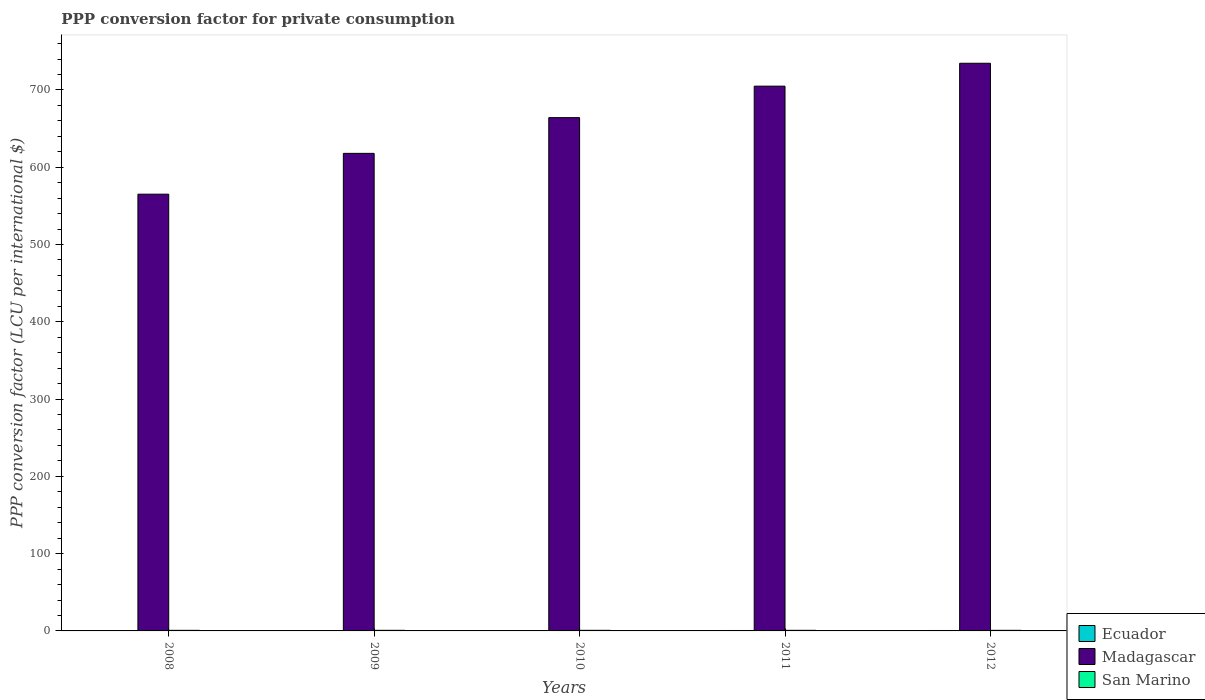How many groups of bars are there?
Offer a very short reply. 5. What is the label of the 2nd group of bars from the left?
Ensure brevity in your answer.  2009. What is the PPP conversion factor for private consumption in San Marino in 2012?
Offer a very short reply. 0.78. Across all years, what is the maximum PPP conversion factor for private consumption in Madagascar?
Your response must be concise. 734.54. Across all years, what is the minimum PPP conversion factor for private consumption in San Marino?
Your answer should be compact. 0.76. In which year was the PPP conversion factor for private consumption in San Marino maximum?
Your answer should be very brief. 2010. In which year was the PPP conversion factor for private consumption in San Marino minimum?
Provide a short and direct response. 2008. What is the total PPP conversion factor for private consumption in San Marino in the graph?
Provide a succinct answer. 3.86. What is the difference between the PPP conversion factor for private consumption in Madagascar in 2008 and that in 2011?
Your response must be concise. -139.79. What is the difference between the PPP conversion factor for private consumption in San Marino in 2008 and the PPP conversion factor for private consumption in Madagascar in 2011?
Your response must be concise. -704.16. What is the average PPP conversion factor for private consumption in Madagascar per year?
Make the answer very short. 657.34. In the year 2012, what is the difference between the PPP conversion factor for private consumption in Ecuador and PPP conversion factor for private consumption in San Marino?
Provide a short and direct response. -0.22. What is the ratio of the PPP conversion factor for private consumption in Ecuador in 2009 to that in 2011?
Give a very brief answer. 0.97. What is the difference between the highest and the second highest PPP conversion factor for private consumption in San Marino?
Your response must be concise. 0. What is the difference between the highest and the lowest PPP conversion factor for private consumption in San Marino?
Offer a very short reply. 0.03. In how many years, is the PPP conversion factor for private consumption in San Marino greater than the average PPP conversion factor for private consumption in San Marino taken over all years?
Your answer should be compact. 4. What does the 2nd bar from the left in 2010 represents?
Keep it short and to the point. Madagascar. What does the 2nd bar from the right in 2010 represents?
Make the answer very short. Madagascar. How many bars are there?
Your response must be concise. 15. Are all the bars in the graph horizontal?
Offer a terse response. No. Are the values on the major ticks of Y-axis written in scientific E-notation?
Provide a short and direct response. No. How many legend labels are there?
Keep it short and to the point. 3. How are the legend labels stacked?
Offer a very short reply. Vertical. What is the title of the graph?
Your answer should be very brief. PPP conversion factor for private consumption. Does "New Zealand" appear as one of the legend labels in the graph?
Your response must be concise. No. What is the label or title of the X-axis?
Your response must be concise. Years. What is the label or title of the Y-axis?
Provide a succinct answer. PPP conversion factor (LCU per international $). What is the PPP conversion factor (LCU per international $) in Ecuador in 2008?
Provide a succinct answer. 0.5. What is the PPP conversion factor (LCU per international $) in Madagascar in 2008?
Offer a terse response. 565.12. What is the PPP conversion factor (LCU per international $) in San Marino in 2008?
Offer a very short reply. 0.76. What is the PPP conversion factor (LCU per international $) in Ecuador in 2009?
Offer a terse response. 0.53. What is the PPP conversion factor (LCU per international $) of Madagascar in 2009?
Provide a succinct answer. 617.94. What is the PPP conversion factor (LCU per international $) in San Marino in 2009?
Your response must be concise. 0.77. What is the PPP conversion factor (LCU per international $) in Ecuador in 2010?
Make the answer very short. 0.54. What is the PPP conversion factor (LCU per international $) in Madagascar in 2010?
Ensure brevity in your answer.  664.18. What is the PPP conversion factor (LCU per international $) of San Marino in 2010?
Provide a short and direct response. 0.78. What is the PPP conversion factor (LCU per international $) of Ecuador in 2011?
Offer a terse response. 0.55. What is the PPP conversion factor (LCU per international $) of Madagascar in 2011?
Offer a very short reply. 704.91. What is the PPP conversion factor (LCU per international $) of San Marino in 2011?
Keep it short and to the point. 0.77. What is the PPP conversion factor (LCU per international $) of Ecuador in 2012?
Offer a terse response. 0.56. What is the PPP conversion factor (LCU per international $) of Madagascar in 2012?
Ensure brevity in your answer.  734.54. What is the PPP conversion factor (LCU per international $) in San Marino in 2012?
Offer a terse response. 0.78. Across all years, what is the maximum PPP conversion factor (LCU per international $) in Ecuador?
Make the answer very short. 0.56. Across all years, what is the maximum PPP conversion factor (LCU per international $) of Madagascar?
Offer a terse response. 734.54. Across all years, what is the maximum PPP conversion factor (LCU per international $) in San Marino?
Provide a succinct answer. 0.78. Across all years, what is the minimum PPP conversion factor (LCU per international $) in Ecuador?
Your answer should be compact. 0.5. Across all years, what is the minimum PPP conversion factor (LCU per international $) of Madagascar?
Give a very brief answer. 565.12. Across all years, what is the minimum PPP conversion factor (LCU per international $) of San Marino?
Your answer should be compact. 0.76. What is the total PPP conversion factor (LCU per international $) of Ecuador in the graph?
Ensure brevity in your answer.  2.68. What is the total PPP conversion factor (LCU per international $) of Madagascar in the graph?
Your answer should be compact. 3286.7. What is the total PPP conversion factor (LCU per international $) in San Marino in the graph?
Provide a short and direct response. 3.86. What is the difference between the PPP conversion factor (LCU per international $) of Ecuador in 2008 and that in 2009?
Your response must be concise. -0.03. What is the difference between the PPP conversion factor (LCU per international $) in Madagascar in 2008 and that in 2009?
Your response must be concise. -52.81. What is the difference between the PPP conversion factor (LCU per international $) in San Marino in 2008 and that in 2009?
Offer a very short reply. -0.02. What is the difference between the PPP conversion factor (LCU per international $) in Ecuador in 2008 and that in 2010?
Offer a terse response. -0.04. What is the difference between the PPP conversion factor (LCU per international $) in Madagascar in 2008 and that in 2010?
Make the answer very short. -99.06. What is the difference between the PPP conversion factor (LCU per international $) in San Marino in 2008 and that in 2010?
Offer a very short reply. -0.03. What is the difference between the PPP conversion factor (LCU per international $) of Ecuador in 2008 and that in 2011?
Your response must be concise. -0.04. What is the difference between the PPP conversion factor (LCU per international $) in Madagascar in 2008 and that in 2011?
Your answer should be very brief. -139.79. What is the difference between the PPP conversion factor (LCU per international $) of San Marino in 2008 and that in 2011?
Your response must be concise. -0.02. What is the difference between the PPP conversion factor (LCU per international $) of Ecuador in 2008 and that in 2012?
Provide a short and direct response. -0.06. What is the difference between the PPP conversion factor (LCU per international $) of Madagascar in 2008 and that in 2012?
Make the answer very short. -169.41. What is the difference between the PPP conversion factor (LCU per international $) of San Marino in 2008 and that in 2012?
Your answer should be compact. -0.02. What is the difference between the PPP conversion factor (LCU per international $) in Ecuador in 2009 and that in 2010?
Provide a short and direct response. -0.01. What is the difference between the PPP conversion factor (LCU per international $) of Madagascar in 2009 and that in 2010?
Provide a short and direct response. -46.25. What is the difference between the PPP conversion factor (LCU per international $) in San Marino in 2009 and that in 2010?
Give a very brief answer. -0.01. What is the difference between the PPP conversion factor (LCU per international $) of Ecuador in 2009 and that in 2011?
Offer a very short reply. -0.02. What is the difference between the PPP conversion factor (LCU per international $) of Madagascar in 2009 and that in 2011?
Provide a succinct answer. -86.97. What is the difference between the PPP conversion factor (LCU per international $) of San Marino in 2009 and that in 2011?
Make the answer very short. 0. What is the difference between the PPP conversion factor (LCU per international $) in Ecuador in 2009 and that in 2012?
Offer a very short reply. -0.03. What is the difference between the PPP conversion factor (LCU per international $) of Madagascar in 2009 and that in 2012?
Make the answer very short. -116.6. What is the difference between the PPP conversion factor (LCU per international $) in San Marino in 2009 and that in 2012?
Make the answer very short. -0. What is the difference between the PPP conversion factor (LCU per international $) in Ecuador in 2010 and that in 2011?
Offer a terse response. -0.01. What is the difference between the PPP conversion factor (LCU per international $) of Madagascar in 2010 and that in 2011?
Give a very brief answer. -40.73. What is the difference between the PPP conversion factor (LCU per international $) of San Marino in 2010 and that in 2011?
Give a very brief answer. 0.01. What is the difference between the PPP conversion factor (LCU per international $) in Ecuador in 2010 and that in 2012?
Ensure brevity in your answer.  -0.02. What is the difference between the PPP conversion factor (LCU per international $) of Madagascar in 2010 and that in 2012?
Offer a terse response. -70.35. What is the difference between the PPP conversion factor (LCU per international $) of San Marino in 2010 and that in 2012?
Your answer should be compact. 0. What is the difference between the PPP conversion factor (LCU per international $) in Ecuador in 2011 and that in 2012?
Provide a succinct answer. -0.02. What is the difference between the PPP conversion factor (LCU per international $) in Madagascar in 2011 and that in 2012?
Provide a short and direct response. -29.62. What is the difference between the PPP conversion factor (LCU per international $) of San Marino in 2011 and that in 2012?
Offer a very short reply. -0.01. What is the difference between the PPP conversion factor (LCU per international $) of Ecuador in 2008 and the PPP conversion factor (LCU per international $) of Madagascar in 2009?
Offer a terse response. -617.44. What is the difference between the PPP conversion factor (LCU per international $) in Ecuador in 2008 and the PPP conversion factor (LCU per international $) in San Marino in 2009?
Provide a succinct answer. -0.27. What is the difference between the PPP conversion factor (LCU per international $) of Madagascar in 2008 and the PPP conversion factor (LCU per international $) of San Marino in 2009?
Offer a very short reply. 564.35. What is the difference between the PPP conversion factor (LCU per international $) in Ecuador in 2008 and the PPP conversion factor (LCU per international $) in Madagascar in 2010?
Offer a terse response. -663.68. What is the difference between the PPP conversion factor (LCU per international $) in Ecuador in 2008 and the PPP conversion factor (LCU per international $) in San Marino in 2010?
Your answer should be very brief. -0.28. What is the difference between the PPP conversion factor (LCU per international $) of Madagascar in 2008 and the PPP conversion factor (LCU per international $) of San Marino in 2010?
Offer a terse response. 564.34. What is the difference between the PPP conversion factor (LCU per international $) in Ecuador in 2008 and the PPP conversion factor (LCU per international $) in Madagascar in 2011?
Your answer should be very brief. -704.41. What is the difference between the PPP conversion factor (LCU per international $) of Ecuador in 2008 and the PPP conversion factor (LCU per international $) of San Marino in 2011?
Your answer should be compact. -0.27. What is the difference between the PPP conversion factor (LCU per international $) in Madagascar in 2008 and the PPP conversion factor (LCU per international $) in San Marino in 2011?
Keep it short and to the point. 564.35. What is the difference between the PPP conversion factor (LCU per international $) in Ecuador in 2008 and the PPP conversion factor (LCU per international $) in Madagascar in 2012?
Your response must be concise. -734.03. What is the difference between the PPP conversion factor (LCU per international $) in Ecuador in 2008 and the PPP conversion factor (LCU per international $) in San Marino in 2012?
Give a very brief answer. -0.28. What is the difference between the PPP conversion factor (LCU per international $) of Madagascar in 2008 and the PPP conversion factor (LCU per international $) of San Marino in 2012?
Keep it short and to the point. 564.35. What is the difference between the PPP conversion factor (LCU per international $) of Ecuador in 2009 and the PPP conversion factor (LCU per international $) of Madagascar in 2010?
Keep it short and to the point. -663.65. What is the difference between the PPP conversion factor (LCU per international $) of Ecuador in 2009 and the PPP conversion factor (LCU per international $) of San Marino in 2010?
Offer a terse response. -0.25. What is the difference between the PPP conversion factor (LCU per international $) in Madagascar in 2009 and the PPP conversion factor (LCU per international $) in San Marino in 2010?
Offer a very short reply. 617.16. What is the difference between the PPP conversion factor (LCU per international $) in Ecuador in 2009 and the PPP conversion factor (LCU per international $) in Madagascar in 2011?
Offer a terse response. -704.38. What is the difference between the PPP conversion factor (LCU per international $) of Ecuador in 2009 and the PPP conversion factor (LCU per international $) of San Marino in 2011?
Offer a very short reply. -0.24. What is the difference between the PPP conversion factor (LCU per international $) of Madagascar in 2009 and the PPP conversion factor (LCU per international $) of San Marino in 2011?
Make the answer very short. 617.17. What is the difference between the PPP conversion factor (LCU per international $) of Ecuador in 2009 and the PPP conversion factor (LCU per international $) of Madagascar in 2012?
Offer a very short reply. -734.01. What is the difference between the PPP conversion factor (LCU per international $) in Ecuador in 2009 and the PPP conversion factor (LCU per international $) in San Marino in 2012?
Your response must be concise. -0.25. What is the difference between the PPP conversion factor (LCU per international $) of Madagascar in 2009 and the PPP conversion factor (LCU per international $) of San Marino in 2012?
Keep it short and to the point. 617.16. What is the difference between the PPP conversion factor (LCU per international $) of Ecuador in 2010 and the PPP conversion factor (LCU per international $) of Madagascar in 2011?
Provide a succinct answer. -704.37. What is the difference between the PPP conversion factor (LCU per international $) in Ecuador in 2010 and the PPP conversion factor (LCU per international $) in San Marino in 2011?
Give a very brief answer. -0.23. What is the difference between the PPP conversion factor (LCU per international $) in Madagascar in 2010 and the PPP conversion factor (LCU per international $) in San Marino in 2011?
Your response must be concise. 663.41. What is the difference between the PPP conversion factor (LCU per international $) of Ecuador in 2010 and the PPP conversion factor (LCU per international $) of Madagascar in 2012?
Make the answer very short. -734. What is the difference between the PPP conversion factor (LCU per international $) of Ecuador in 2010 and the PPP conversion factor (LCU per international $) of San Marino in 2012?
Provide a succinct answer. -0.24. What is the difference between the PPP conversion factor (LCU per international $) in Madagascar in 2010 and the PPP conversion factor (LCU per international $) in San Marino in 2012?
Make the answer very short. 663.41. What is the difference between the PPP conversion factor (LCU per international $) in Ecuador in 2011 and the PPP conversion factor (LCU per international $) in Madagascar in 2012?
Offer a very short reply. -733.99. What is the difference between the PPP conversion factor (LCU per international $) in Ecuador in 2011 and the PPP conversion factor (LCU per international $) in San Marino in 2012?
Offer a terse response. -0.23. What is the difference between the PPP conversion factor (LCU per international $) of Madagascar in 2011 and the PPP conversion factor (LCU per international $) of San Marino in 2012?
Make the answer very short. 704.13. What is the average PPP conversion factor (LCU per international $) in Ecuador per year?
Make the answer very short. 0.54. What is the average PPP conversion factor (LCU per international $) in Madagascar per year?
Your response must be concise. 657.34. What is the average PPP conversion factor (LCU per international $) in San Marino per year?
Your answer should be very brief. 0.77. In the year 2008, what is the difference between the PPP conversion factor (LCU per international $) of Ecuador and PPP conversion factor (LCU per international $) of Madagascar?
Your answer should be compact. -564.62. In the year 2008, what is the difference between the PPP conversion factor (LCU per international $) of Ecuador and PPP conversion factor (LCU per international $) of San Marino?
Give a very brief answer. -0.25. In the year 2008, what is the difference between the PPP conversion factor (LCU per international $) in Madagascar and PPP conversion factor (LCU per international $) in San Marino?
Your answer should be very brief. 564.37. In the year 2009, what is the difference between the PPP conversion factor (LCU per international $) in Ecuador and PPP conversion factor (LCU per international $) in Madagascar?
Offer a terse response. -617.41. In the year 2009, what is the difference between the PPP conversion factor (LCU per international $) in Ecuador and PPP conversion factor (LCU per international $) in San Marino?
Your response must be concise. -0.24. In the year 2009, what is the difference between the PPP conversion factor (LCU per international $) in Madagascar and PPP conversion factor (LCU per international $) in San Marino?
Provide a succinct answer. 617.16. In the year 2010, what is the difference between the PPP conversion factor (LCU per international $) in Ecuador and PPP conversion factor (LCU per international $) in Madagascar?
Make the answer very short. -663.64. In the year 2010, what is the difference between the PPP conversion factor (LCU per international $) in Ecuador and PPP conversion factor (LCU per international $) in San Marino?
Provide a succinct answer. -0.24. In the year 2010, what is the difference between the PPP conversion factor (LCU per international $) of Madagascar and PPP conversion factor (LCU per international $) of San Marino?
Your response must be concise. 663.4. In the year 2011, what is the difference between the PPP conversion factor (LCU per international $) in Ecuador and PPP conversion factor (LCU per international $) in Madagascar?
Your answer should be very brief. -704.37. In the year 2011, what is the difference between the PPP conversion factor (LCU per international $) of Ecuador and PPP conversion factor (LCU per international $) of San Marino?
Your answer should be very brief. -0.23. In the year 2011, what is the difference between the PPP conversion factor (LCU per international $) of Madagascar and PPP conversion factor (LCU per international $) of San Marino?
Offer a terse response. 704.14. In the year 2012, what is the difference between the PPP conversion factor (LCU per international $) of Ecuador and PPP conversion factor (LCU per international $) of Madagascar?
Provide a succinct answer. -733.97. In the year 2012, what is the difference between the PPP conversion factor (LCU per international $) of Ecuador and PPP conversion factor (LCU per international $) of San Marino?
Make the answer very short. -0.22. In the year 2012, what is the difference between the PPP conversion factor (LCU per international $) of Madagascar and PPP conversion factor (LCU per international $) of San Marino?
Give a very brief answer. 733.76. What is the ratio of the PPP conversion factor (LCU per international $) of Ecuador in 2008 to that in 2009?
Your response must be concise. 0.95. What is the ratio of the PPP conversion factor (LCU per international $) of Madagascar in 2008 to that in 2009?
Your response must be concise. 0.91. What is the ratio of the PPP conversion factor (LCU per international $) of San Marino in 2008 to that in 2009?
Your response must be concise. 0.97. What is the ratio of the PPP conversion factor (LCU per international $) in Madagascar in 2008 to that in 2010?
Your answer should be very brief. 0.85. What is the ratio of the PPP conversion factor (LCU per international $) in San Marino in 2008 to that in 2010?
Offer a very short reply. 0.97. What is the ratio of the PPP conversion factor (LCU per international $) of Ecuador in 2008 to that in 2011?
Ensure brevity in your answer.  0.92. What is the ratio of the PPP conversion factor (LCU per international $) of Madagascar in 2008 to that in 2011?
Offer a very short reply. 0.8. What is the ratio of the PPP conversion factor (LCU per international $) of San Marino in 2008 to that in 2011?
Offer a very short reply. 0.98. What is the ratio of the PPP conversion factor (LCU per international $) of Ecuador in 2008 to that in 2012?
Keep it short and to the point. 0.89. What is the ratio of the PPP conversion factor (LCU per international $) in Madagascar in 2008 to that in 2012?
Offer a terse response. 0.77. What is the ratio of the PPP conversion factor (LCU per international $) in San Marino in 2008 to that in 2012?
Your answer should be very brief. 0.97. What is the ratio of the PPP conversion factor (LCU per international $) in Ecuador in 2009 to that in 2010?
Provide a short and direct response. 0.98. What is the ratio of the PPP conversion factor (LCU per international $) of Madagascar in 2009 to that in 2010?
Your response must be concise. 0.93. What is the ratio of the PPP conversion factor (LCU per international $) in Ecuador in 2009 to that in 2011?
Make the answer very short. 0.97. What is the ratio of the PPP conversion factor (LCU per international $) of Madagascar in 2009 to that in 2011?
Provide a succinct answer. 0.88. What is the ratio of the PPP conversion factor (LCU per international $) in Madagascar in 2009 to that in 2012?
Your answer should be very brief. 0.84. What is the ratio of the PPP conversion factor (LCU per international $) of Ecuador in 2010 to that in 2011?
Give a very brief answer. 0.99. What is the ratio of the PPP conversion factor (LCU per international $) in Madagascar in 2010 to that in 2011?
Provide a succinct answer. 0.94. What is the ratio of the PPP conversion factor (LCU per international $) in San Marino in 2010 to that in 2011?
Make the answer very short. 1.01. What is the ratio of the PPP conversion factor (LCU per international $) of Ecuador in 2010 to that in 2012?
Your answer should be very brief. 0.96. What is the ratio of the PPP conversion factor (LCU per international $) in Madagascar in 2010 to that in 2012?
Offer a very short reply. 0.9. What is the ratio of the PPP conversion factor (LCU per international $) of Ecuador in 2011 to that in 2012?
Your answer should be very brief. 0.97. What is the ratio of the PPP conversion factor (LCU per international $) of Madagascar in 2011 to that in 2012?
Keep it short and to the point. 0.96. What is the difference between the highest and the second highest PPP conversion factor (LCU per international $) in Ecuador?
Your answer should be very brief. 0.02. What is the difference between the highest and the second highest PPP conversion factor (LCU per international $) of Madagascar?
Offer a very short reply. 29.62. What is the difference between the highest and the second highest PPP conversion factor (LCU per international $) in San Marino?
Provide a succinct answer. 0. What is the difference between the highest and the lowest PPP conversion factor (LCU per international $) of Ecuador?
Make the answer very short. 0.06. What is the difference between the highest and the lowest PPP conversion factor (LCU per international $) of Madagascar?
Keep it short and to the point. 169.41. What is the difference between the highest and the lowest PPP conversion factor (LCU per international $) of San Marino?
Your response must be concise. 0.03. 